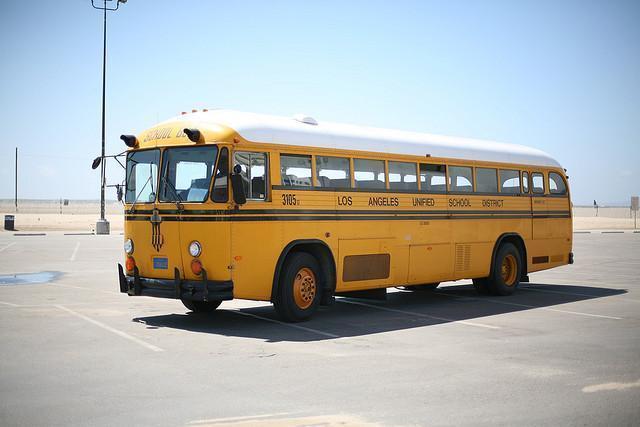How many buses are shown?
Give a very brief answer. 1. How many tires on the bus?
Give a very brief answer. 4. How many lights are at the top front of the bus?
Give a very brief answer. 2. How many busses do you see?
Give a very brief answer. 1. How many brown horses are there?
Give a very brief answer. 0. 